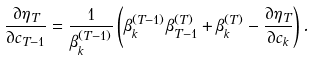<formula> <loc_0><loc_0><loc_500><loc_500>\frac { \partial \eta _ { T } } { \partial c _ { T - 1 } } = \frac { 1 } { \beta ^ { ( T - 1 ) } _ { k } } \left ( \beta ^ { ( T - 1 ) } _ { k } \beta ^ { ( T ) } _ { T - 1 } + \beta ^ { ( T ) } _ { k } - \frac { \partial \eta _ { T } } { \partial c _ { k } } \right ) .</formula> 